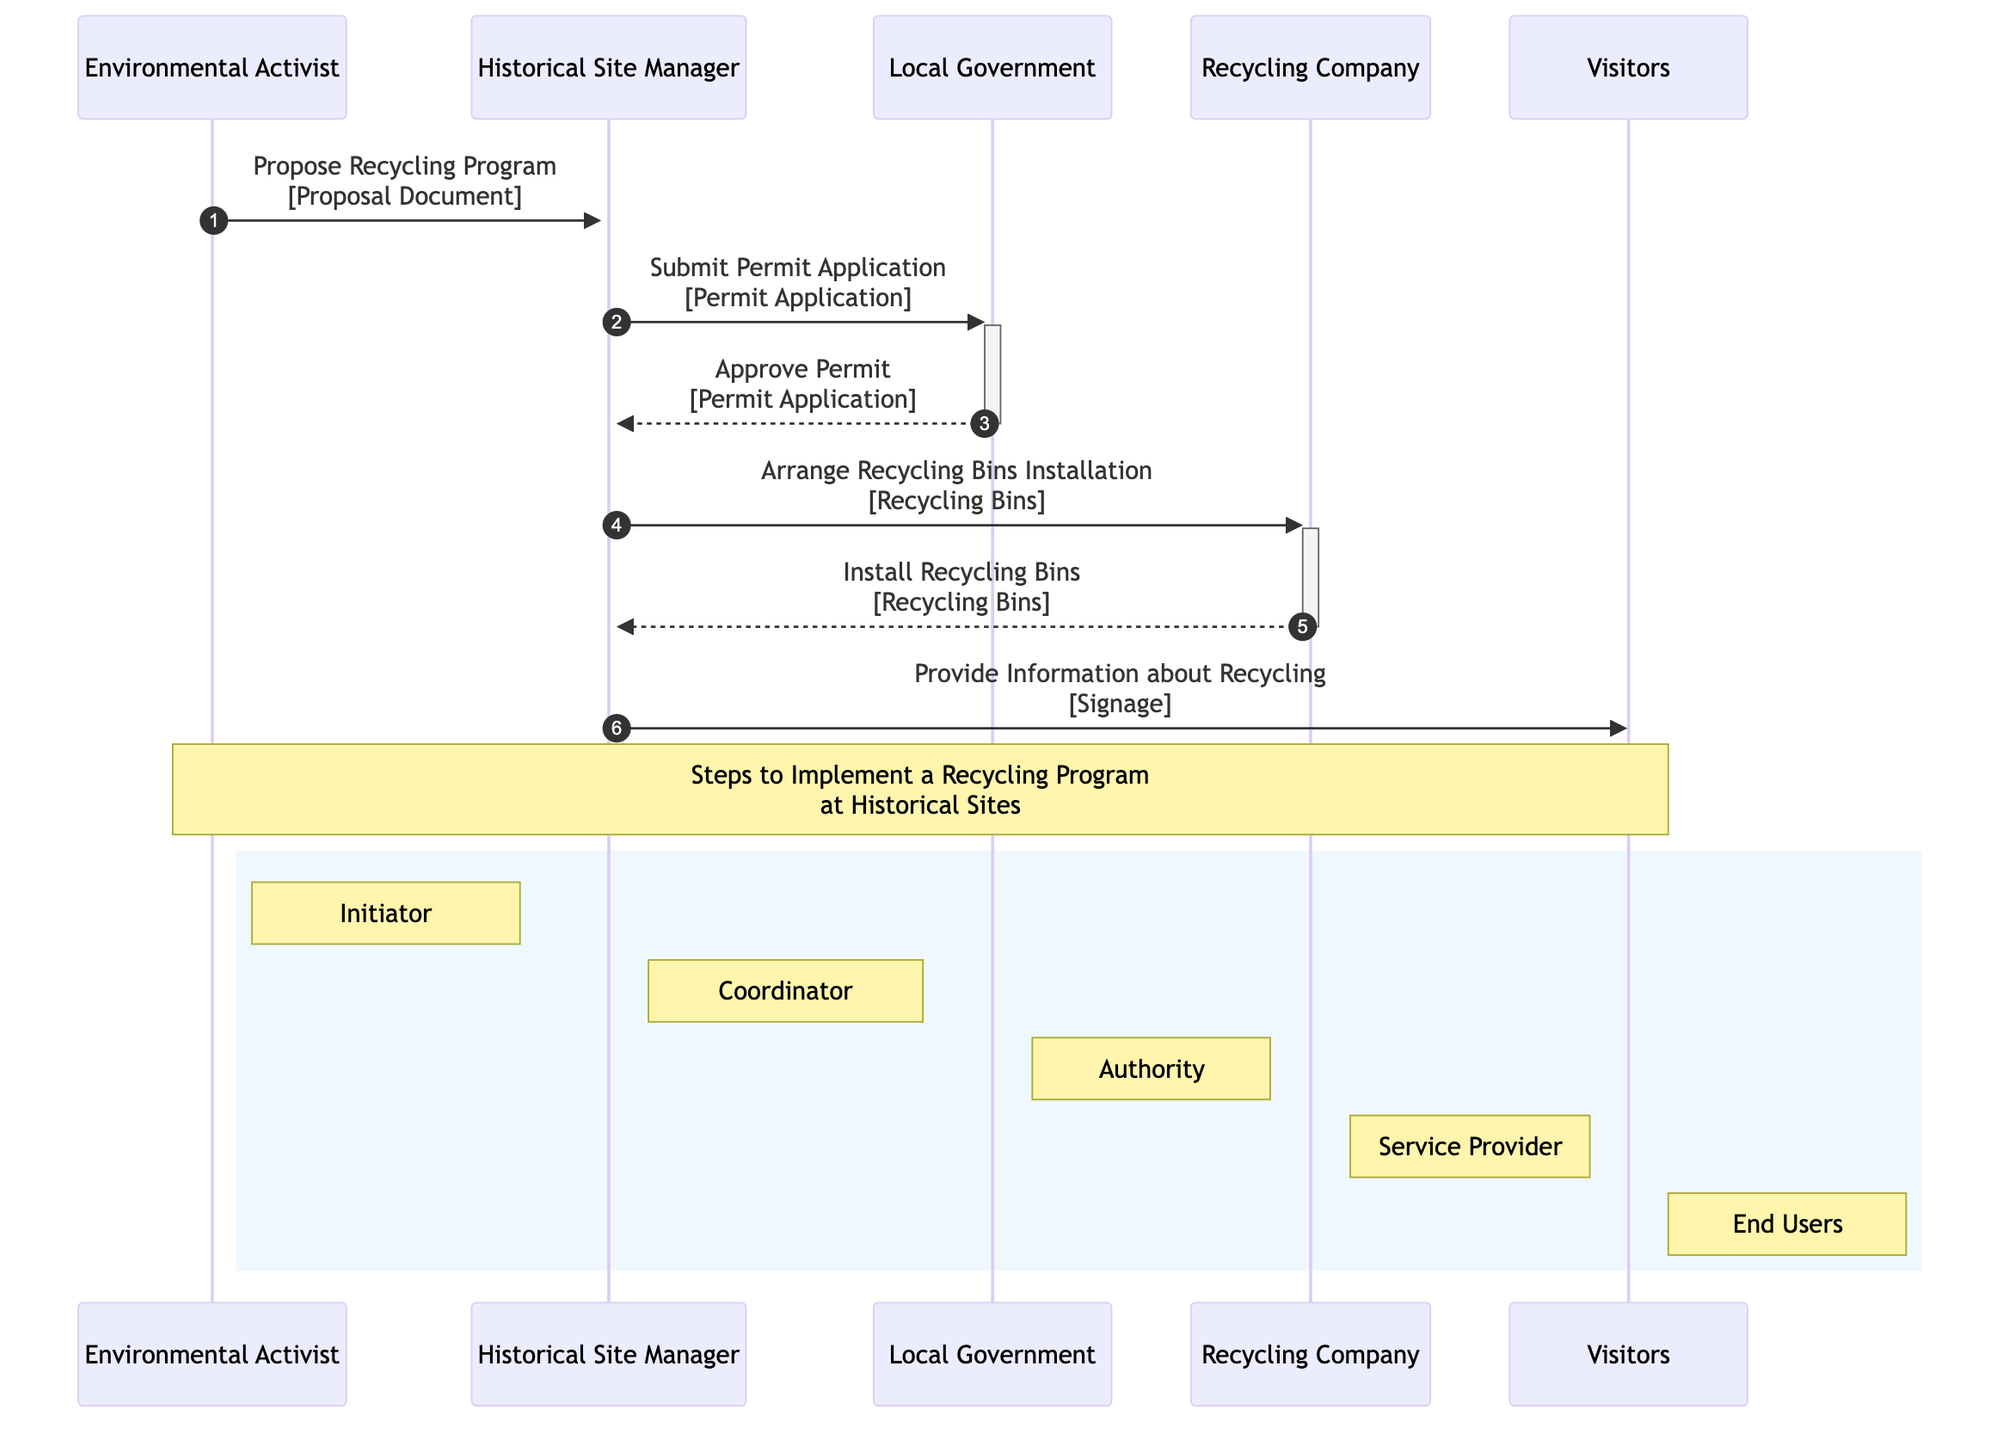What is the first action in the diagram? The first action in the diagram is the Environmental Activist proposing a Recycling Program to the Historical Site Manager. This is identified by the first arrow pointing from Environmental Activist to Historical Site Manager labeled "Propose Recycling Program" along with the Proposal Document.
Answer: Propose Recycling Program Who submits the Permit Application? The Historical Site Manager is responsible for submitting the Permit Application, as indicated by the arrow going from Historical Site Manager to Local Government with the message "Submit Permit Application."
Answer: Historical Site Manager How many messages are exchanged between the Local Government and Historical Site Manager? Two messages are exchanged between the Local Government and Historical Site Manager: one where the Historical Site Manager submits a Permit Application and another where the Local Government approves this application. This can be seen in the two distinct arrows connecting these two participants.
Answer: Two What equipment is used for recycling at the historical site? The equipment used are Recycling Bins and Signage. Recycling Bins are organized by the Recycling Company, whereas Signage is provided to inform Visitors about recycling. Both are referenced in the interactions concerning recycling implementation.
Answer: Recycling Bins, Signage Which role has the authority in the process? The Local Government holds the authority in this process, as it is responsible for approving the Permit Application submitted by the Historical Site Manager. This relationship is indicated by the arrow from Local Government to Historical Site Manager with the message "Approve Permit."
Answer: Local Government What action takes place after the Permit is approved? After the Permit is approved, the Historical Site Manager arranges for the installation of Recycling Bins with the Recycling Company. This is shown by the arrow depicting the Historical Site Manager contacting the Recycling Company with the message "Arrange Recycling Bins Installation."
Answer: Arrange Recycling Bins Installation How do Visitors receive information about recycling? Visitors receive information about recycling through Signage provided by the Historical Site Manager, as indicated by the direct message from Historical Site Manager to Visitors labeled "Provide Information about Recycling."
Answer: Signage What is the sequence of actions from initiation to informing visitors? The sequence starts with the Environmental Activist proposing the Recycling Program, followed by the Historical Site Manager submitting the Permit Application. After the Local Government approves it, the Historical Site Manager arranges for installing Recycling Bins by the Recycling Company, which then installs the bins. Finally, the Historical Site Manager provides information to Visitors. This sequence shows how actions are interconnected through the roles involved.
Answer: Environmental Activist → Historical Site Manager → Local Government → Recycling Company → Visitors 